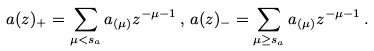Convert formula to latex. <formula><loc_0><loc_0><loc_500><loc_500>a ( z ) _ { + } = \sum _ { \mu < s _ { a } } a _ { ( \mu ) } z ^ { - \mu - 1 } \, , \, a ( z ) _ { - } = \sum _ { \mu \geq s _ { a } } a _ { ( \mu ) } z ^ { - \mu - 1 } \, .</formula> 